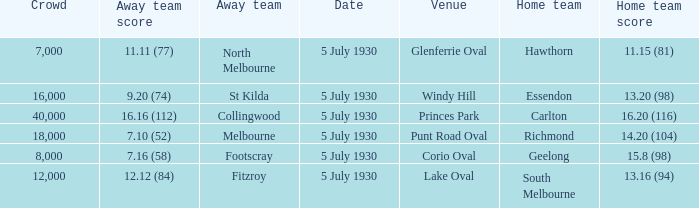Who is the away side at corio oval? Footscray. 